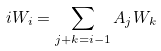Convert formula to latex. <formula><loc_0><loc_0><loc_500><loc_500>i W _ { i } = \sum _ { j + k = i - 1 } A _ { j } W _ { k }</formula> 